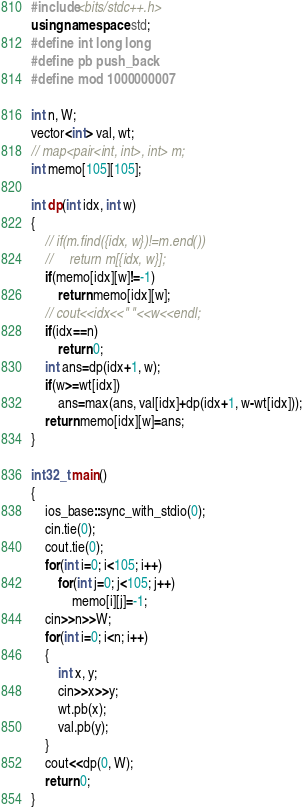Convert code to text. <code><loc_0><loc_0><loc_500><loc_500><_C++_>#include<bits/stdc++.h>
using namespace std;
#define int long long
#define pb push_back
#define mod 1000000007

int n, W;
vector<int> val, wt;
// map<pair<int, int>, int> m;
int memo[105][105];

int dp(int idx, int w)
{
    // if(m.find({idx, w})!=m.end())
    //     return m[{idx, w}];
    if(memo[idx][w]!=-1)
        return memo[idx][w];
    // cout<<idx<<" "<<w<<endl;
    if(idx==n)
        return 0;
    int ans=dp(idx+1, w);
    if(w>=wt[idx])
        ans=max(ans, val[idx]+dp(idx+1, w-wt[idx]));
    return memo[idx][w]=ans;
}

int32_t main()
{
    ios_base::sync_with_stdio(0);
    cin.tie(0);
    cout.tie(0);
    for(int i=0; i<105; i++)
        for(int j=0; j<105; j++)
            memo[i][j]=-1;
    cin>>n>>W;
    for(int i=0; i<n; i++)
    {
        int x, y;
        cin>>x>>y;
        wt.pb(x);
        val.pb(y);
    }
    cout<<dp(0, W);
    return 0;
}</code> 